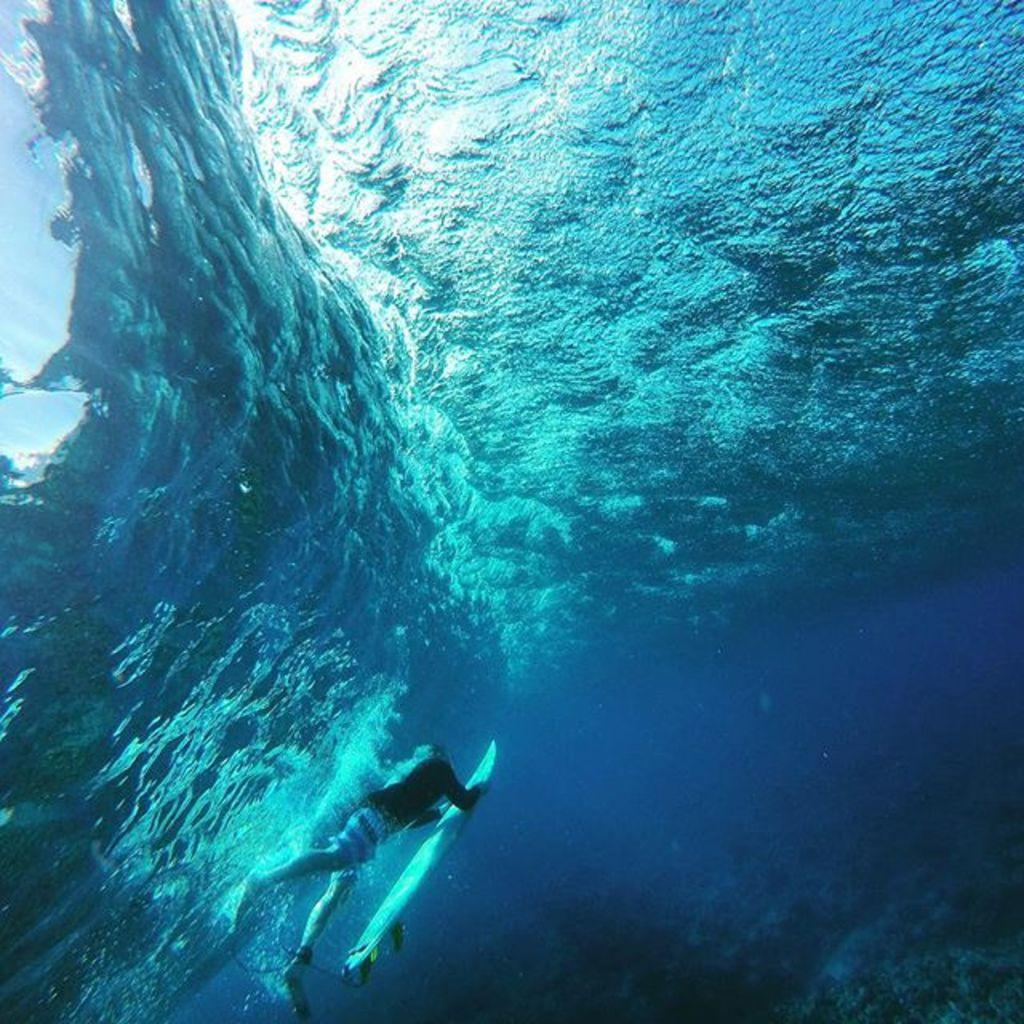Who is present in the image? There is a man in the image. What is the man holding in the image? The man is holding a surfing board. Where are the man and the surfing board located in the image? The man and the surfing board are in the water. What type of coat is the man wearing in the image? The man is not wearing a coat in the image; he is in the water holding a surfing board. 